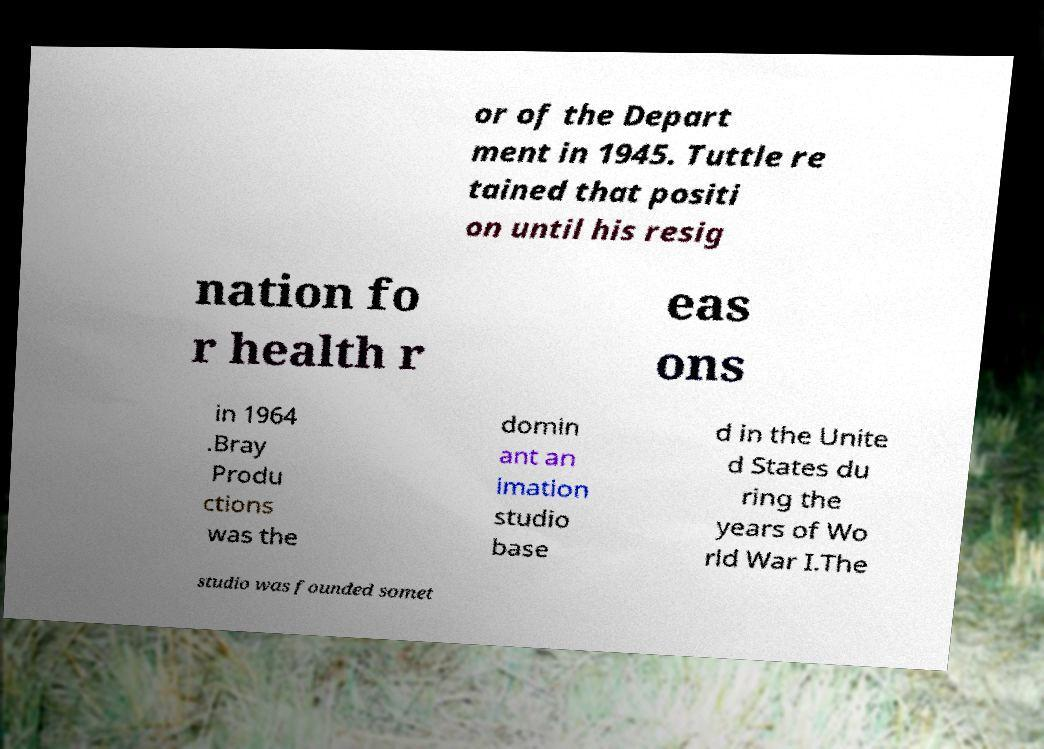Can you accurately transcribe the text from the provided image for me? or of the Depart ment in 1945. Tuttle re tained that positi on until his resig nation fo r health r eas ons in 1964 .Bray Produ ctions was the domin ant an imation studio base d in the Unite d States du ring the years of Wo rld War I.The studio was founded somet 